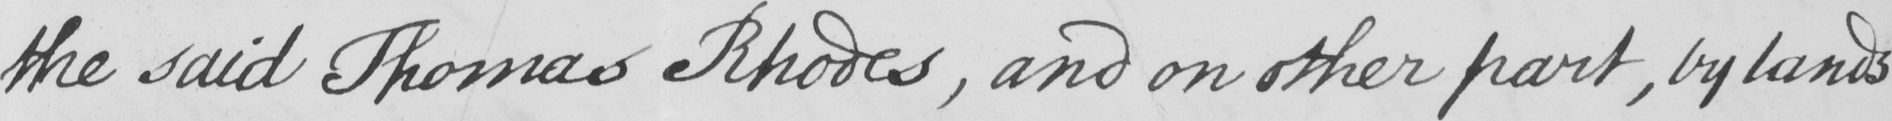Transcribe the text shown in this historical manuscript line. the said Thomas Rhodes , and on other part , by lands 